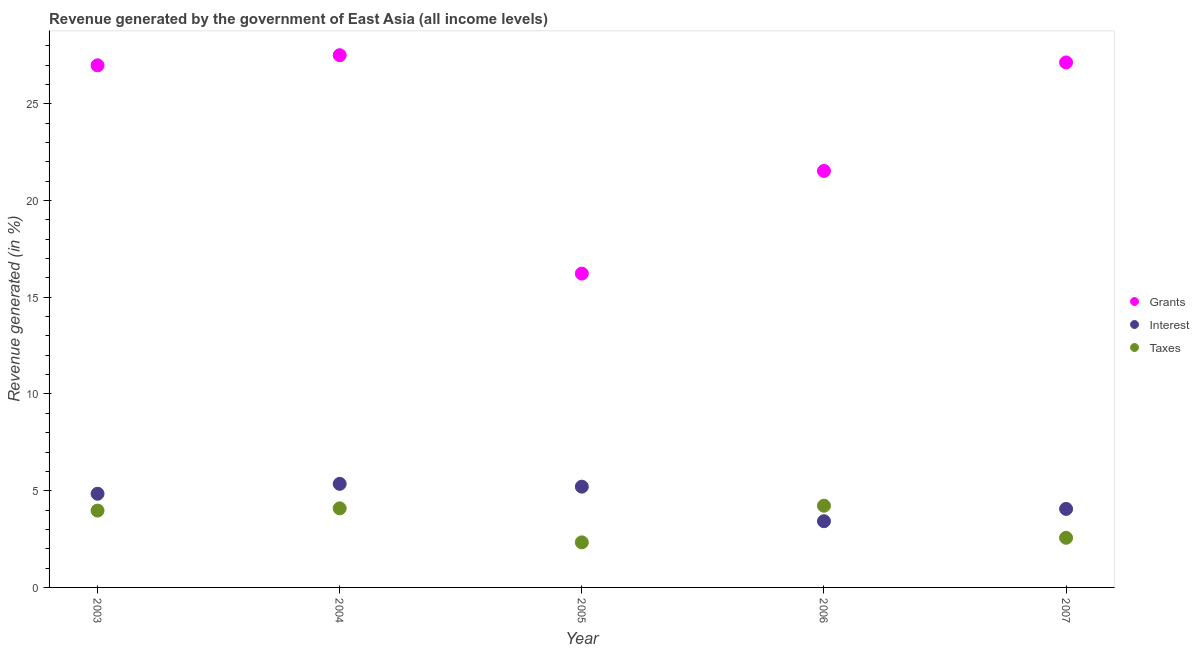Is the number of dotlines equal to the number of legend labels?
Ensure brevity in your answer.  Yes. What is the percentage of revenue generated by interest in 2007?
Your answer should be compact. 4.06. Across all years, what is the maximum percentage of revenue generated by taxes?
Offer a very short reply. 4.22. Across all years, what is the minimum percentage of revenue generated by grants?
Offer a terse response. 16.22. In which year was the percentage of revenue generated by grants minimum?
Your answer should be compact. 2005. What is the total percentage of revenue generated by taxes in the graph?
Offer a very short reply. 17.18. What is the difference between the percentage of revenue generated by taxes in 2004 and that in 2007?
Your response must be concise. 1.52. What is the difference between the percentage of revenue generated by interest in 2003 and the percentage of revenue generated by grants in 2006?
Make the answer very short. -16.69. What is the average percentage of revenue generated by interest per year?
Your response must be concise. 4.58. In the year 2005, what is the difference between the percentage of revenue generated by interest and percentage of revenue generated by taxes?
Your answer should be compact. 2.88. What is the ratio of the percentage of revenue generated by taxes in 2003 to that in 2005?
Make the answer very short. 1.7. Is the percentage of revenue generated by interest in 2005 less than that in 2007?
Your response must be concise. No. Is the difference between the percentage of revenue generated by taxes in 2003 and 2007 greater than the difference between the percentage of revenue generated by interest in 2003 and 2007?
Your response must be concise. Yes. What is the difference between the highest and the second highest percentage of revenue generated by interest?
Your response must be concise. 0.15. What is the difference between the highest and the lowest percentage of revenue generated by interest?
Ensure brevity in your answer.  1.93. In how many years, is the percentage of revenue generated by interest greater than the average percentage of revenue generated by interest taken over all years?
Provide a succinct answer. 3. Is the sum of the percentage of revenue generated by grants in 2005 and 2007 greater than the maximum percentage of revenue generated by interest across all years?
Your answer should be very brief. Yes. Is the percentage of revenue generated by interest strictly greater than the percentage of revenue generated by grants over the years?
Provide a short and direct response. No. Is the percentage of revenue generated by taxes strictly less than the percentage of revenue generated by interest over the years?
Keep it short and to the point. No. How many dotlines are there?
Your answer should be very brief. 3. How many years are there in the graph?
Provide a short and direct response. 5. What is the difference between two consecutive major ticks on the Y-axis?
Your answer should be very brief. 5. Does the graph contain any zero values?
Give a very brief answer. No. Does the graph contain grids?
Make the answer very short. No. Where does the legend appear in the graph?
Provide a succinct answer. Center right. What is the title of the graph?
Provide a short and direct response. Revenue generated by the government of East Asia (all income levels). What is the label or title of the X-axis?
Your response must be concise. Year. What is the label or title of the Y-axis?
Make the answer very short. Revenue generated (in %). What is the Revenue generated (in %) of Grants in 2003?
Provide a short and direct response. 26.99. What is the Revenue generated (in %) in Interest in 2003?
Your response must be concise. 4.84. What is the Revenue generated (in %) in Taxes in 2003?
Your answer should be compact. 3.97. What is the Revenue generated (in %) in Grants in 2004?
Ensure brevity in your answer.  27.51. What is the Revenue generated (in %) in Interest in 2004?
Give a very brief answer. 5.35. What is the Revenue generated (in %) in Taxes in 2004?
Give a very brief answer. 4.09. What is the Revenue generated (in %) in Grants in 2005?
Keep it short and to the point. 16.22. What is the Revenue generated (in %) of Interest in 2005?
Your answer should be very brief. 5.21. What is the Revenue generated (in %) in Taxes in 2005?
Your response must be concise. 2.33. What is the Revenue generated (in %) in Grants in 2006?
Give a very brief answer. 21.53. What is the Revenue generated (in %) of Interest in 2006?
Your answer should be compact. 3.42. What is the Revenue generated (in %) of Taxes in 2006?
Provide a succinct answer. 4.22. What is the Revenue generated (in %) of Grants in 2007?
Your answer should be compact. 27.14. What is the Revenue generated (in %) of Interest in 2007?
Ensure brevity in your answer.  4.06. What is the Revenue generated (in %) of Taxes in 2007?
Offer a very short reply. 2.57. Across all years, what is the maximum Revenue generated (in %) in Grants?
Provide a succinct answer. 27.51. Across all years, what is the maximum Revenue generated (in %) of Interest?
Your answer should be compact. 5.35. Across all years, what is the maximum Revenue generated (in %) in Taxes?
Your response must be concise. 4.22. Across all years, what is the minimum Revenue generated (in %) in Grants?
Provide a succinct answer. 16.22. Across all years, what is the minimum Revenue generated (in %) in Interest?
Provide a succinct answer. 3.42. Across all years, what is the minimum Revenue generated (in %) in Taxes?
Offer a very short reply. 2.33. What is the total Revenue generated (in %) in Grants in the graph?
Provide a succinct answer. 119.39. What is the total Revenue generated (in %) of Interest in the graph?
Give a very brief answer. 22.89. What is the total Revenue generated (in %) of Taxes in the graph?
Provide a succinct answer. 17.18. What is the difference between the Revenue generated (in %) in Grants in 2003 and that in 2004?
Offer a terse response. -0.52. What is the difference between the Revenue generated (in %) in Interest in 2003 and that in 2004?
Provide a succinct answer. -0.51. What is the difference between the Revenue generated (in %) in Taxes in 2003 and that in 2004?
Provide a succinct answer. -0.12. What is the difference between the Revenue generated (in %) of Grants in 2003 and that in 2005?
Give a very brief answer. 10.77. What is the difference between the Revenue generated (in %) in Interest in 2003 and that in 2005?
Provide a succinct answer. -0.37. What is the difference between the Revenue generated (in %) in Taxes in 2003 and that in 2005?
Your answer should be compact. 1.64. What is the difference between the Revenue generated (in %) of Grants in 2003 and that in 2006?
Ensure brevity in your answer.  5.46. What is the difference between the Revenue generated (in %) in Interest in 2003 and that in 2006?
Your response must be concise. 1.42. What is the difference between the Revenue generated (in %) in Taxes in 2003 and that in 2006?
Provide a short and direct response. -0.25. What is the difference between the Revenue generated (in %) in Grants in 2003 and that in 2007?
Provide a succinct answer. -0.15. What is the difference between the Revenue generated (in %) of Interest in 2003 and that in 2007?
Keep it short and to the point. 0.78. What is the difference between the Revenue generated (in %) of Taxes in 2003 and that in 2007?
Provide a succinct answer. 1.41. What is the difference between the Revenue generated (in %) in Grants in 2004 and that in 2005?
Offer a terse response. 11.29. What is the difference between the Revenue generated (in %) in Interest in 2004 and that in 2005?
Keep it short and to the point. 0.15. What is the difference between the Revenue generated (in %) of Taxes in 2004 and that in 2005?
Provide a succinct answer. 1.76. What is the difference between the Revenue generated (in %) of Grants in 2004 and that in 2006?
Offer a terse response. 5.98. What is the difference between the Revenue generated (in %) of Interest in 2004 and that in 2006?
Give a very brief answer. 1.93. What is the difference between the Revenue generated (in %) of Taxes in 2004 and that in 2006?
Provide a short and direct response. -0.14. What is the difference between the Revenue generated (in %) of Grants in 2004 and that in 2007?
Keep it short and to the point. 0.37. What is the difference between the Revenue generated (in %) of Interest in 2004 and that in 2007?
Offer a terse response. 1.29. What is the difference between the Revenue generated (in %) in Taxes in 2004 and that in 2007?
Provide a short and direct response. 1.52. What is the difference between the Revenue generated (in %) in Grants in 2005 and that in 2006?
Provide a short and direct response. -5.31. What is the difference between the Revenue generated (in %) in Interest in 2005 and that in 2006?
Ensure brevity in your answer.  1.79. What is the difference between the Revenue generated (in %) of Taxes in 2005 and that in 2006?
Keep it short and to the point. -1.89. What is the difference between the Revenue generated (in %) in Grants in 2005 and that in 2007?
Keep it short and to the point. -10.91. What is the difference between the Revenue generated (in %) of Interest in 2005 and that in 2007?
Ensure brevity in your answer.  1.15. What is the difference between the Revenue generated (in %) of Taxes in 2005 and that in 2007?
Offer a very short reply. -0.24. What is the difference between the Revenue generated (in %) of Grants in 2006 and that in 2007?
Provide a succinct answer. -5.61. What is the difference between the Revenue generated (in %) in Interest in 2006 and that in 2007?
Ensure brevity in your answer.  -0.64. What is the difference between the Revenue generated (in %) in Taxes in 2006 and that in 2007?
Your response must be concise. 1.66. What is the difference between the Revenue generated (in %) in Grants in 2003 and the Revenue generated (in %) in Interest in 2004?
Provide a short and direct response. 21.63. What is the difference between the Revenue generated (in %) of Grants in 2003 and the Revenue generated (in %) of Taxes in 2004?
Your answer should be very brief. 22.9. What is the difference between the Revenue generated (in %) in Interest in 2003 and the Revenue generated (in %) in Taxes in 2004?
Offer a terse response. 0.76. What is the difference between the Revenue generated (in %) of Grants in 2003 and the Revenue generated (in %) of Interest in 2005?
Provide a short and direct response. 21.78. What is the difference between the Revenue generated (in %) of Grants in 2003 and the Revenue generated (in %) of Taxes in 2005?
Make the answer very short. 24.66. What is the difference between the Revenue generated (in %) of Interest in 2003 and the Revenue generated (in %) of Taxes in 2005?
Your answer should be compact. 2.51. What is the difference between the Revenue generated (in %) in Grants in 2003 and the Revenue generated (in %) in Interest in 2006?
Your answer should be compact. 23.57. What is the difference between the Revenue generated (in %) of Grants in 2003 and the Revenue generated (in %) of Taxes in 2006?
Offer a very short reply. 22.77. What is the difference between the Revenue generated (in %) of Interest in 2003 and the Revenue generated (in %) of Taxes in 2006?
Make the answer very short. 0.62. What is the difference between the Revenue generated (in %) of Grants in 2003 and the Revenue generated (in %) of Interest in 2007?
Your answer should be very brief. 22.93. What is the difference between the Revenue generated (in %) in Grants in 2003 and the Revenue generated (in %) in Taxes in 2007?
Make the answer very short. 24.42. What is the difference between the Revenue generated (in %) of Interest in 2003 and the Revenue generated (in %) of Taxes in 2007?
Keep it short and to the point. 2.28. What is the difference between the Revenue generated (in %) of Grants in 2004 and the Revenue generated (in %) of Interest in 2005?
Your response must be concise. 22.3. What is the difference between the Revenue generated (in %) in Grants in 2004 and the Revenue generated (in %) in Taxes in 2005?
Your response must be concise. 25.18. What is the difference between the Revenue generated (in %) of Interest in 2004 and the Revenue generated (in %) of Taxes in 2005?
Give a very brief answer. 3.02. What is the difference between the Revenue generated (in %) of Grants in 2004 and the Revenue generated (in %) of Interest in 2006?
Provide a succinct answer. 24.09. What is the difference between the Revenue generated (in %) of Grants in 2004 and the Revenue generated (in %) of Taxes in 2006?
Ensure brevity in your answer.  23.29. What is the difference between the Revenue generated (in %) of Interest in 2004 and the Revenue generated (in %) of Taxes in 2006?
Keep it short and to the point. 1.13. What is the difference between the Revenue generated (in %) in Grants in 2004 and the Revenue generated (in %) in Interest in 2007?
Offer a very short reply. 23.45. What is the difference between the Revenue generated (in %) in Grants in 2004 and the Revenue generated (in %) in Taxes in 2007?
Your response must be concise. 24.95. What is the difference between the Revenue generated (in %) in Interest in 2004 and the Revenue generated (in %) in Taxes in 2007?
Offer a terse response. 2.79. What is the difference between the Revenue generated (in %) of Grants in 2005 and the Revenue generated (in %) of Interest in 2006?
Ensure brevity in your answer.  12.8. What is the difference between the Revenue generated (in %) in Grants in 2005 and the Revenue generated (in %) in Taxes in 2006?
Provide a succinct answer. 12. What is the difference between the Revenue generated (in %) of Interest in 2005 and the Revenue generated (in %) of Taxes in 2006?
Ensure brevity in your answer.  0.99. What is the difference between the Revenue generated (in %) in Grants in 2005 and the Revenue generated (in %) in Interest in 2007?
Your answer should be compact. 12.16. What is the difference between the Revenue generated (in %) in Grants in 2005 and the Revenue generated (in %) in Taxes in 2007?
Offer a very short reply. 13.66. What is the difference between the Revenue generated (in %) in Interest in 2005 and the Revenue generated (in %) in Taxes in 2007?
Give a very brief answer. 2.64. What is the difference between the Revenue generated (in %) in Grants in 2006 and the Revenue generated (in %) in Interest in 2007?
Offer a terse response. 17.47. What is the difference between the Revenue generated (in %) in Grants in 2006 and the Revenue generated (in %) in Taxes in 2007?
Provide a succinct answer. 18.96. What is the difference between the Revenue generated (in %) of Interest in 2006 and the Revenue generated (in %) of Taxes in 2007?
Provide a succinct answer. 0.86. What is the average Revenue generated (in %) of Grants per year?
Your answer should be compact. 23.88. What is the average Revenue generated (in %) of Interest per year?
Your answer should be compact. 4.58. What is the average Revenue generated (in %) in Taxes per year?
Offer a terse response. 3.44. In the year 2003, what is the difference between the Revenue generated (in %) of Grants and Revenue generated (in %) of Interest?
Provide a succinct answer. 22.15. In the year 2003, what is the difference between the Revenue generated (in %) of Grants and Revenue generated (in %) of Taxes?
Your response must be concise. 23.02. In the year 2003, what is the difference between the Revenue generated (in %) of Interest and Revenue generated (in %) of Taxes?
Make the answer very short. 0.87. In the year 2004, what is the difference between the Revenue generated (in %) in Grants and Revenue generated (in %) in Interest?
Make the answer very short. 22.16. In the year 2004, what is the difference between the Revenue generated (in %) of Grants and Revenue generated (in %) of Taxes?
Ensure brevity in your answer.  23.43. In the year 2004, what is the difference between the Revenue generated (in %) of Interest and Revenue generated (in %) of Taxes?
Provide a short and direct response. 1.27. In the year 2005, what is the difference between the Revenue generated (in %) of Grants and Revenue generated (in %) of Interest?
Provide a succinct answer. 11.01. In the year 2005, what is the difference between the Revenue generated (in %) of Grants and Revenue generated (in %) of Taxes?
Provide a succinct answer. 13.89. In the year 2005, what is the difference between the Revenue generated (in %) in Interest and Revenue generated (in %) in Taxes?
Your answer should be very brief. 2.88. In the year 2006, what is the difference between the Revenue generated (in %) in Grants and Revenue generated (in %) in Interest?
Offer a terse response. 18.11. In the year 2006, what is the difference between the Revenue generated (in %) in Grants and Revenue generated (in %) in Taxes?
Your answer should be compact. 17.31. In the year 2006, what is the difference between the Revenue generated (in %) of Interest and Revenue generated (in %) of Taxes?
Offer a very short reply. -0.8. In the year 2007, what is the difference between the Revenue generated (in %) in Grants and Revenue generated (in %) in Interest?
Make the answer very short. 23.08. In the year 2007, what is the difference between the Revenue generated (in %) of Grants and Revenue generated (in %) of Taxes?
Ensure brevity in your answer.  24.57. In the year 2007, what is the difference between the Revenue generated (in %) in Interest and Revenue generated (in %) in Taxes?
Keep it short and to the point. 1.49. What is the ratio of the Revenue generated (in %) of Grants in 2003 to that in 2004?
Ensure brevity in your answer.  0.98. What is the ratio of the Revenue generated (in %) in Interest in 2003 to that in 2004?
Your response must be concise. 0.9. What is the ratio of the Revenue generated (in %) of Taxes in 2003 to that in 2004?
Provide a succinct answer. 0.97. What is the ratio of the Revenue generated (in %) of Grants in 2003 to that in 2005?
Offer a very short reply. 1.66. What is the ratio of the Revenue generated (in %) in Interest in 2003 to that in 2005?
Make the answer very short. 0.93. What is the ratio of the Revenue generated (in %) of Taxes in 2003 to that in 2005?
Offer a very short reply. 1.7. What is the ratio of the Revenue generated (in %) of Grants in 2003 to that in 2006?
Provide a succinct answer. 1.25. What is the ratio of the Revenue generated (in %) of Interest in 2003 to that in 2006?
Provide a succinct answer. 1.41. What is the ratio of the Revenue generated (in %) in Taxes in 2003 to that in 2006?
Keep it short and to the point. 0.94. What is the ratio of the Revenue generated (in %) in Grants in 2003 to that in 2007?
Your answer should be very brief. 0.99. What is the ratio of the Revenue generated (in %) of Interest in 2003 to that in 2007?
Provide a short and direct response. 1.19. What is the ratio of the Revenue generated (in %) of Taxes in 2003 to that in 2007?
Make the answer very short. 1.55. What is the ratio of the Revenue generated (in %) of Grants in 2004 to that in 2005?
Your response must be concise. 1.7. What is the ratio of the Revenue generated (in %) of Interest in 2004 to that in 2005?
Give a very brief answer. 1.03. What is the ratio of the Revenue generated (in %) of Taxes in 2004 to that in 2005?
Offer a very short reply. 1.75. What is the ratio of the Revenue generated (in %) in Grants in 2004 to that in 2006?
Keep it short and to the point. 1.28. What is the ratio of the Revenue generated (in %) in Interest in 2004 to that in 2006?
Provide a succinct answer. 1.56. What is the ratio of the Revenue generated (in %) in Taxes in 2004 to that in 2006?
Make the answer very short. 0.97. What is the ratio of the Revenue generated (in %) in Grants in 2004 to that in 2007?
Your answer should be compact. 1.01. What is the ratio of the Revenue generated (in %) in Interest in 2004 to that in 2007?
Offer a terse response. 1.32. What is the ratio of the Revenue generated (in %) of Taxes in 2004 to that in 2007?
Ensure brevity in your answer.  1.59. What is the ratio of the Revenue generated (in %) in Grants in 2005 to that in 2006?
Offer a terse response. 0.75. What is the ratio of the Revenue generated (in %) in Interest in 2005 to that in 2006?
Ensure brevity in your answer.  1.52. What is the ratio of the Revenue generated (in %) of Taxes in 2005 to that in 2006?
Provide a succinct answer. 0.55. What is the ratio of the Revenue generated (in %) of Grants in 2005 to that in 2007?
Provide a succinct answer. 0.6. What is the ratio of the Revenue generated (in %) in Interest in 2005 to that in 2007?
Ensure brevity in your answer.  1.28. What is the ratio of the Revenue generated (in %) of Taxes in 2005 to that in 2007?
Your answer should be compact. 0.91. What is the ratio of the Revenue generated (in %) of Grants in 2006 to that in 2007?
Your response must be concise. 0.79. What is the ratio of the Revenue generated (in %) of Interest in 2006 to that in 2007?
Keep it short and to the point. 0.84. What is the ratio of the Revenue generated (in %) of Taxes in 2006 to that in 2007?
Offer a very short reply. 1.65. What is the difference between the highest and the second highest Revenue generated (in %) in Grants?
Make the answer very short. 0.37. What is the difference between the highest and the second highest Revenue generated (in %) of Interest?
Ensure brevity in your answer.  0.15. What is the difference between the highest and the second highest Revenue generated (in %) in Taxes?
Make the answer very short. 0.14. What is the difference between the highest and the lowest Revenue generated (in %) of Grants?
Your answer should be very brief. 11.29. What is the difference between the highest and the lowest Revenue generated (in %) of Interest?
Give a very brief answer. 1.93. What is the difference between the highest and the lowest Revenue generated (in %) in Taxes?
Keep it short and to the point. 1.89. 